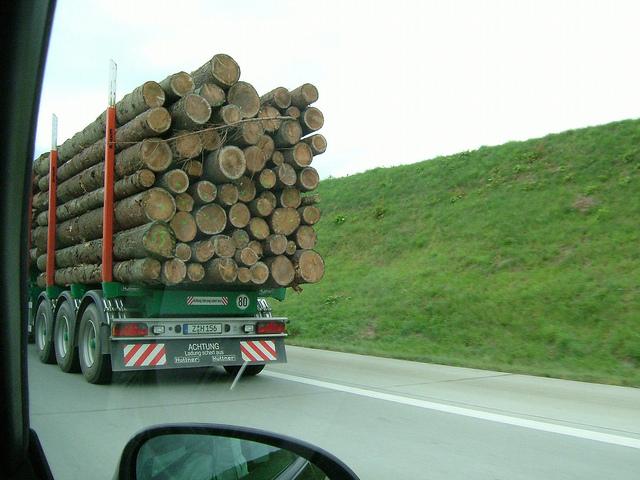What is the color of grass?
Write a very short answer. Green. What is on the truck?
Quick response, please. Logs. What is holding the apples?
Concise answer only. Nothing. What color are the poles?
Answer briefly. Red. 